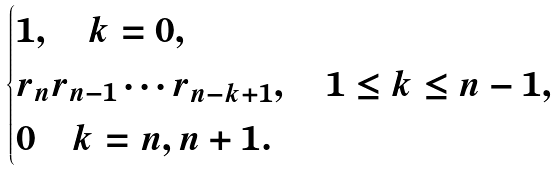Convert formula to latex. <formula><loc_0><loc_0><loc_500><loc_500>\begin{cases} 1 , \quad k = 0 , \\ r _ { n } r _ { n - 1 } \cdots r _ { n - k + 1 } , \quad 1 \leq k \leq n - 1 , \\ 0 \quad k = n , n + 1 . \end{cases}</formula> 